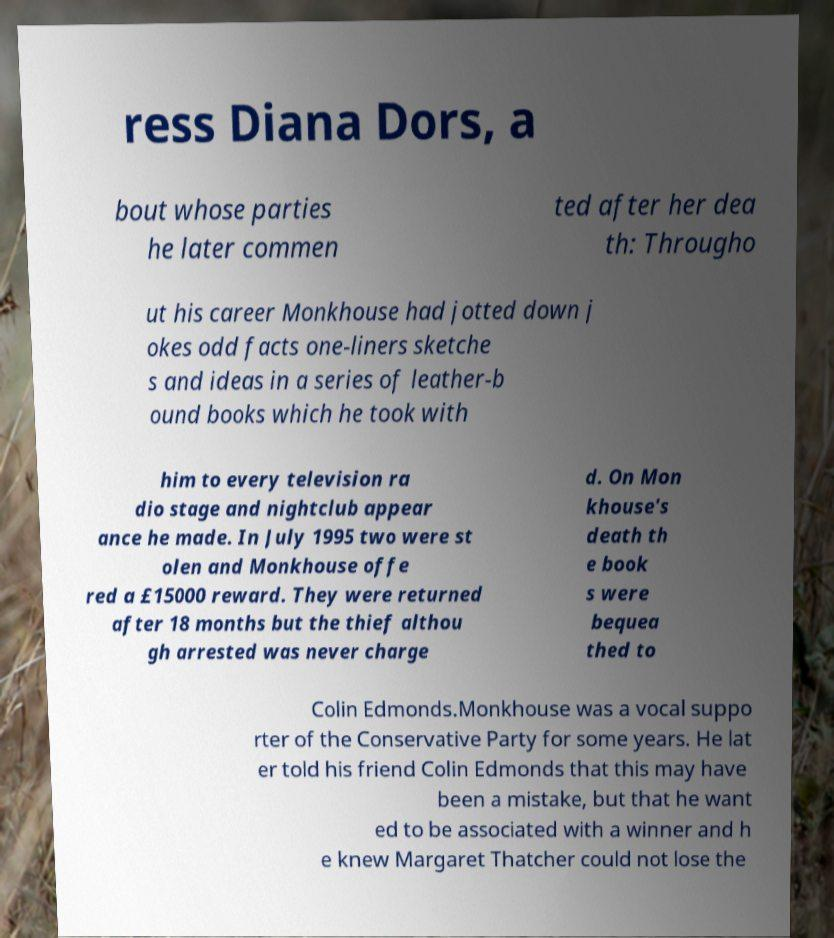Can you accurately transcribe the text from the provided image for me? ress Diana Dors, a bout whose parties he later commen ted after her dea th: Througho ut his career Monkhouse had jotted down j okes odd facts one-liners sketche s and ideas in a series of leather-b ound books which he took with him to every television ra dio stage and nightclub appear ance he made. In July 1995 two were st olen and Monkhouse offe red a £15000 reward. They were returned after 18 months but the thief althou gh arrested was never charge d. On Mon khouse's death th e book s were bequea thed to Colin Edmonds.Monkhouse was a vocal suppo rter of the Conservative Party for some years. He lat er told his friend Colin Edmonds that this may have been a mistake, but that he want ed to be associated with a winner and h e knew Margaret Thatcher could not lose the 